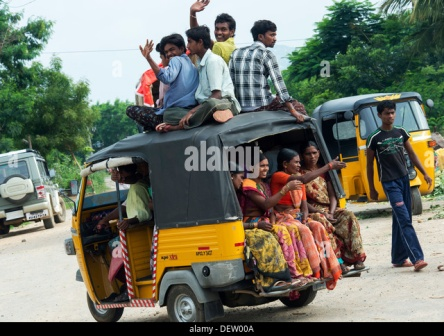Can you describe the different emotions and actions of the people in the image? In the image, there is a distinct contrast between the emotions and actions of the people inside and on top of the rickshaw. The individuals seated on the roof radiate joy and excitement, evidenced by their waving hands and broad smiles. They appear to be exuding a sense of freedom and adventure. Inside the rickshaw, passengers seem more relaxed and observant, gazing out of the windows. Their placid demeanor juxtaposes the roof-riders' enthusiasm, contributing to a multifaceted portrayal of human emotion and interaction. 